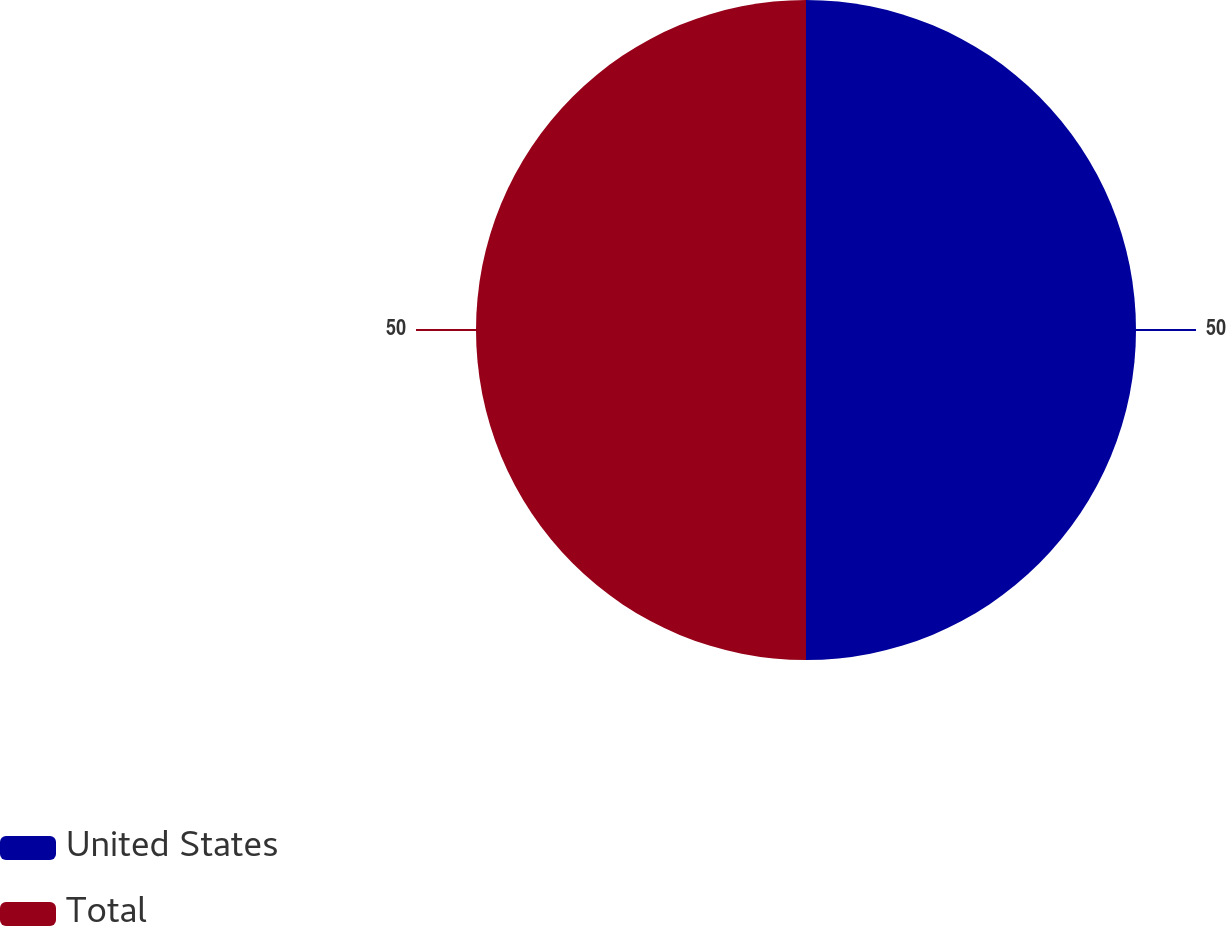<chart> <loc_0><loc_0><loc_500><loc_500><pie_chart><fcel>United States<fcel>Total<nl><fcel>50.0%<fcel>50.0%<nl></chart> 